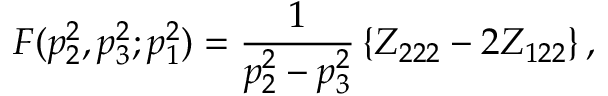Convert formula to latex. <formula><loc_0><loc_0><loc_500><loc_500>F ( p _ { 2 } ^ { 2 } , p _ { 3 } ^ { 2 } ; p _ { 1 } ^ { 2 } ) = \frac { 1 } { p _ { 2 } ^ { 2 } - p _ { 3 } ^ { 2 } } \left \{ Z _ { 2 2 2 } - 2 Z _ { 1 2 2 } \right \} ,</formula> 